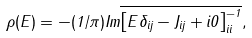Convert formula to latex. <formula><loc_0><loc_0><loc_500><loc_500>\rho ( E ) = - ( { 1 } / { \pi } ) I m \overline { \left [ { E \delta _ { i j } - { J } _ { i j } + i 0 } \right ] _ { i i } ^ { - 1 } } ,</formula> 